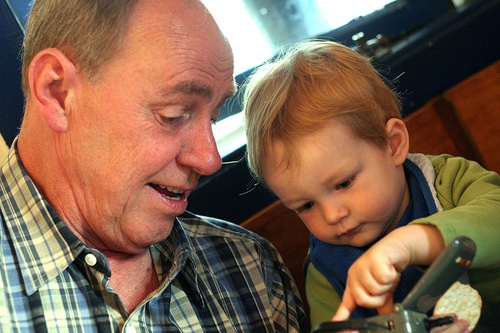Describe the objects in this image and their specific colors. I can see people in darkblue, salmon, black, and brown tones, people in darkblue, brown, black, olive, and tan tones, sink in darkblue, black, teal, and purple tones, cell phone in darkblue, black, darkgreen, and gray tones, and sink in darkblue, black, gray, darkgreen, and lightblue tones in this image. 